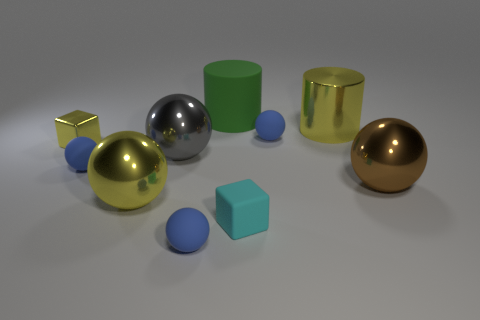How many blue spheres must be subtracted to get 1 blue spheres? 2 Subtract all big yellow shiny balls. How many balls are left? 5 Subtract all yellow cylinders. How many blue spheres are left? 3 Subtract 1 spheres. How many spheres are left? 5 Subtract all gray balls. How many balls are left? 5 Subtract all cylinders. How many objects are left? 8 Subtract 1 green cylinders. How many objects are left? 9 Subtract all gray balls. Subtract all blue cylinders. How many balls are left? 5 Subtract all yellow shiny spheres. Subtract all balls. How many objects are left? 3 Add 5 large gray metal spheres. How many large gray metal spheres are left? 6 